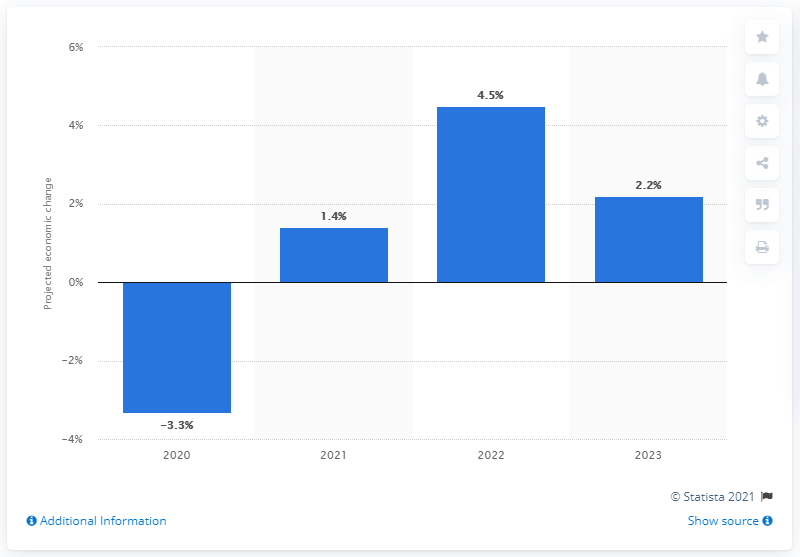Mention a couple of crucial points in this snapshot. The expected growth rate of the Gross Domestic Product (GDP) in 2021 is projected to be 1.4%. Based on current projections, the growth rate for the Danish Gross Domestic Product (GDP) in 2022 is expected to be 4.5%. 